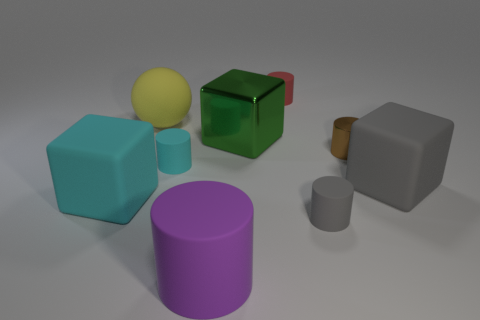Subtract 1 cylinders. How many cylinders are left? 4 Subtract all large rubber cubes. How many cubes are left? 1 Subtract all purple cylinders. How many cylinders are left? 4 Add 1 purple things. How many objects exist? 10 Subtract all gray cylinders. Subtract all green blocks. How many cylinders are left? 4 Subtract all spheres. How many objects are left? 8 Add 3 large green spheres. How many large green spheres exist? 3 Subtract 0 brown cubes. How many objects are left? 9 Subtract all big green balls. Subtract all big cylinders. How many objects are left? 8 Add 8 tiny brown objects. How many tiny brown objects are left? 9 